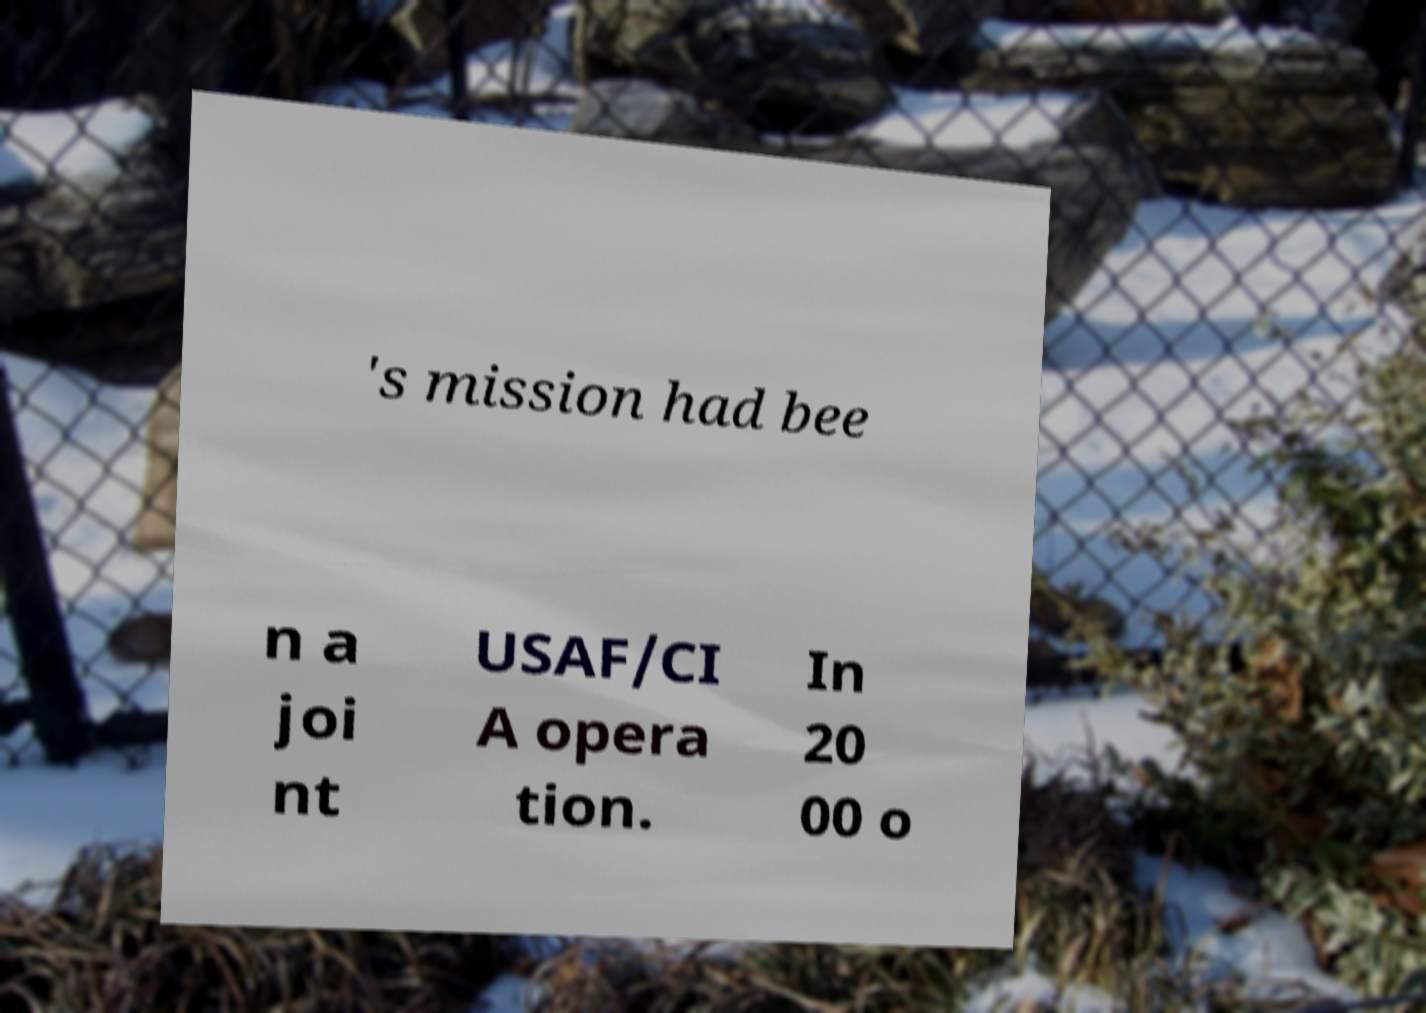Can you read and provide the text displayed in the image?This photo seems to have some interesting text. Can you extract and type it out for me? 's mission had bee n a joi nt USAF/CI A opera tion. In 20 00 o 